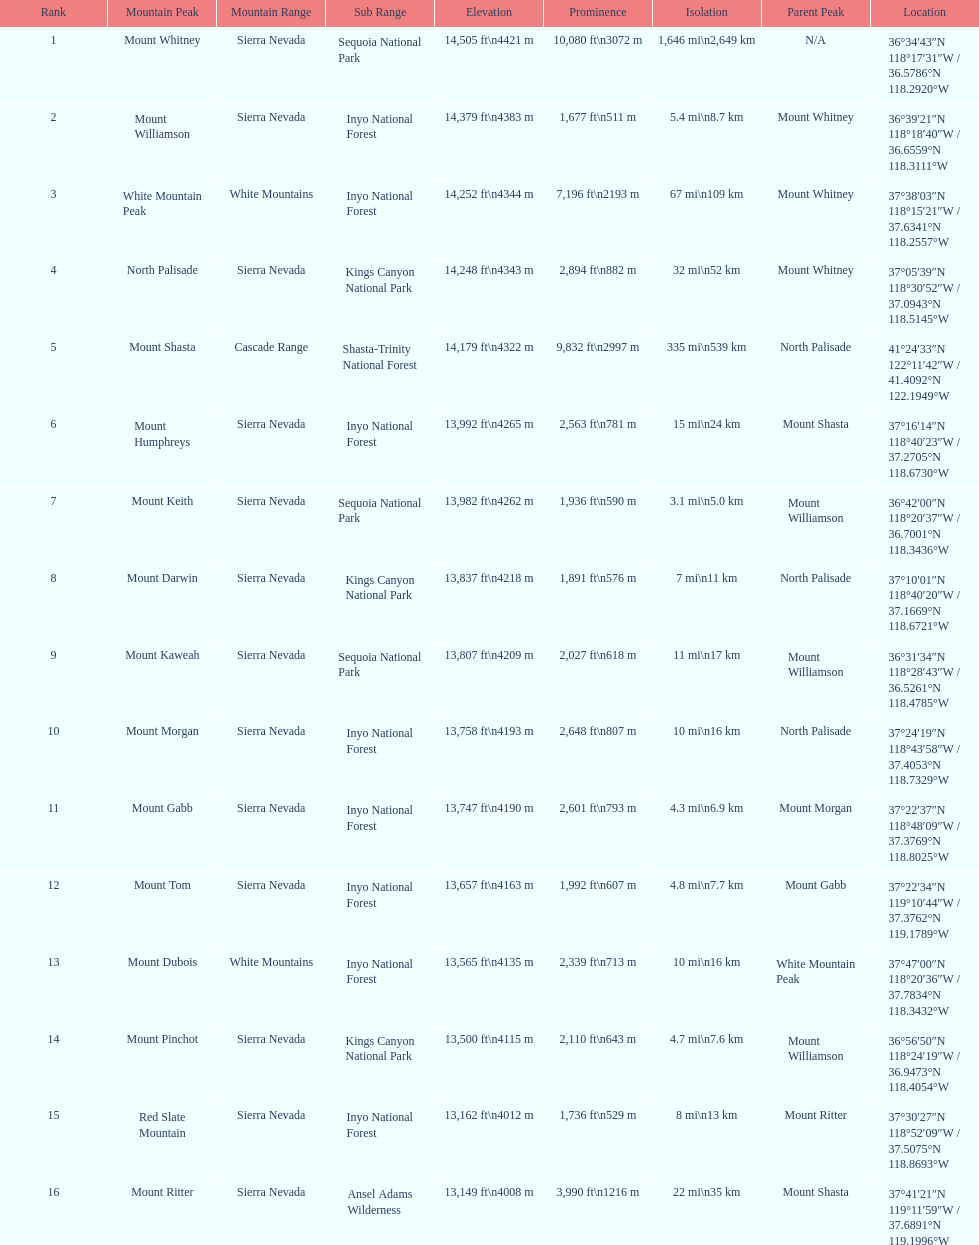How much taller is the mountain peak of mount williamson than that of mount keith? 397 ft. 